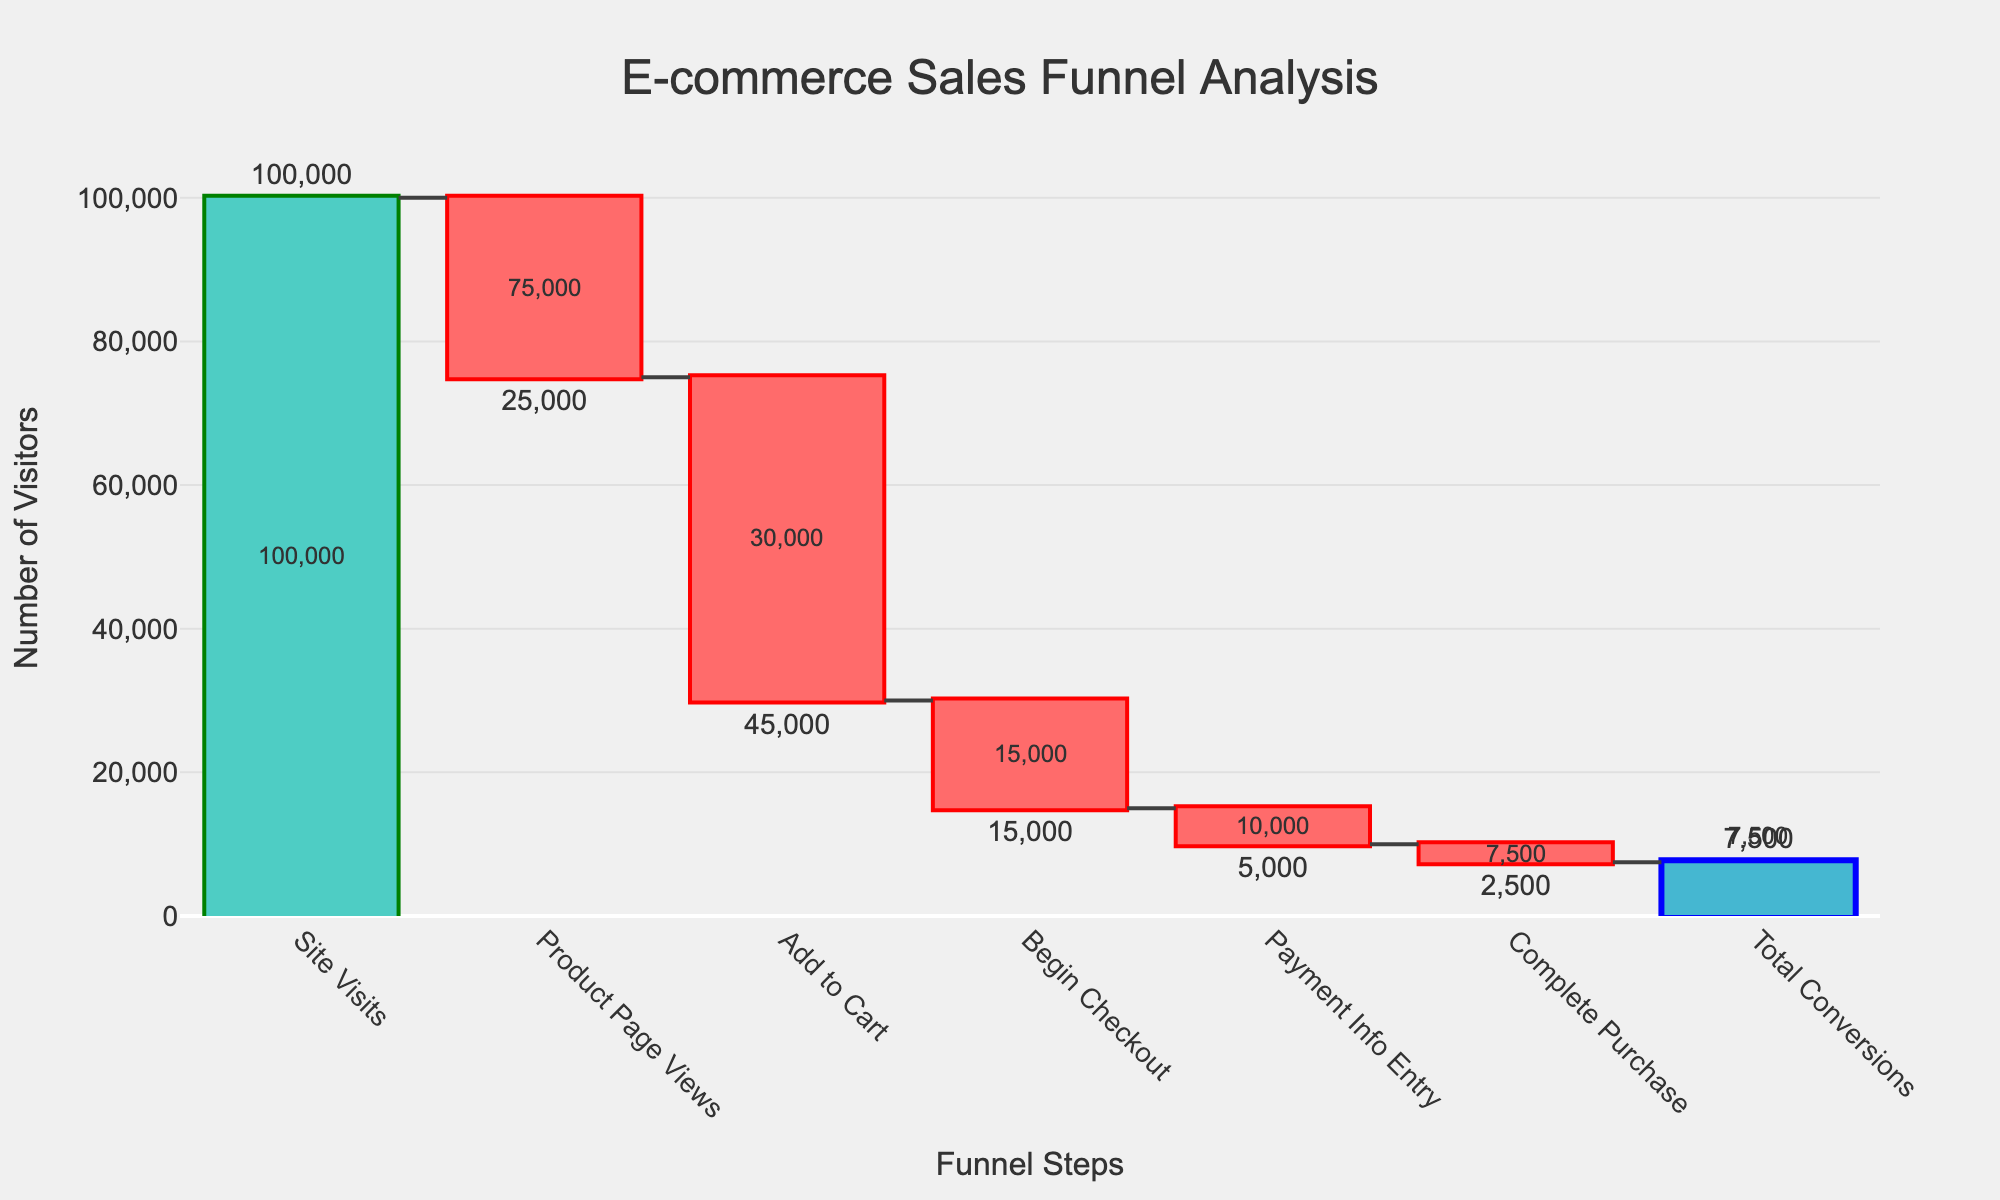What is the title of the chart? The title is displayed at the top of the chart. It reads "E-commerce Sales Funnel Analysis".
Answer: E-commerce Sales Funnel Analysis How many stages are there in the sales funnel? Count the distinct steps along the horizontal axis. There are a total of 7 stages listed in the sales funnel.
Answer: 7 What is the total number of site visits? The value for "Site Visits" is shown at the beginning of the chart, which is 100,000.
Answer: 100,000 What is the drop in visitors from the "Site Visits" stage to the "Product Page Views" stage? Subtract the number of visitors at "Product Page Views" from the number of visitors at "Site Visits": 100,000 - 75,000 = 25,000. The drop is 25,000 visitors.
Answer: 25,000 How does the number of visitors change after the "Add to Cart" stage? Subtract the number of visitors in the "Begin Checkout" stage from those in the "Add to Cart" stage: 30,000 - 15,000 = 15,000. The number of visitors decreases by 15,000.
Answer: Decreases by 15,000 Which stage has the smallest drop in visitor numbers? Highlighted vertical bars correspond to stages with changes. The smallest drop is indicated in "Complete Purchase" stage with a change of -2,500.
Answer: Complete Purchase What percentage of visitors who add to cart eventually complete the purchase? Calculate: (Number of "Complete Purchase" / Number of "Add to Cart") * 100 = (7,500 / 30,000) * 100 ≈ 25%. So, around 25% of visitors who add to cart complete the purchase.
Answer: 25% Compared to "Begin Checkout," how much fewer visitors enter their payment info? Subtract the number of visitors in "Payment Info Entry" from those in "Begin Checkout": 15,000 - 10,000 = 5,000. 5,000 fewer visitors enter their payment information.
Answer: 5,000 Which stage has the highest visitor drop-off? Check the stages for the largest decrease in visitor numbers. The "Add to Cart" stage has the highest drop-off at 45,000 visitors.
Answer: Add to Cart What is the total number of conversions at the end of the funnel? The "Total Conversions" stage shows a final visitor count of 7,500.
Answer: 7,500 